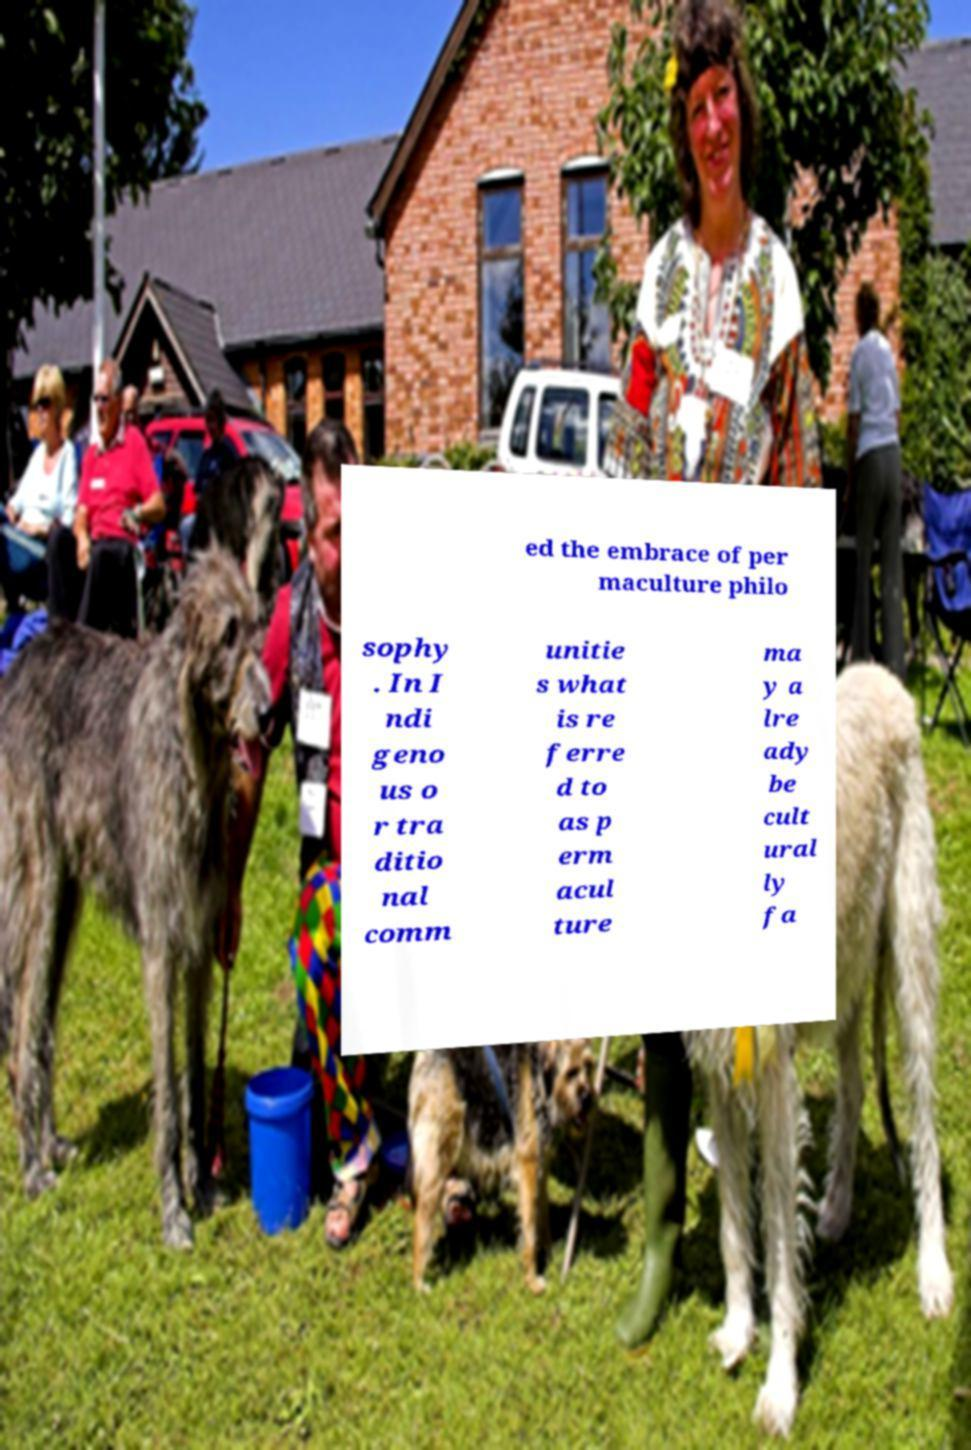For documentation purposes, I need the text within this image transcribed. Could you provide that? ed the embrace of per maculture philo sophy . In I ndi geno us o r tra ditio nal comm unitie s what is re ferre d to as p erm acul ture ma y a lre ady be cult ural ly fa 